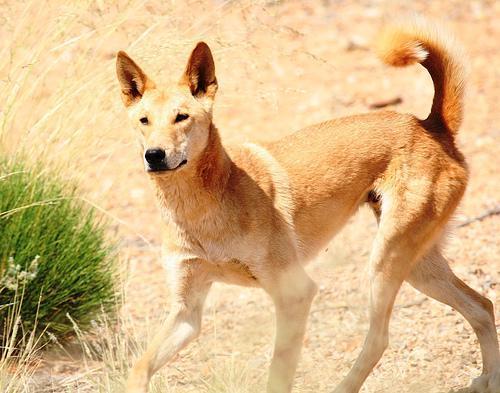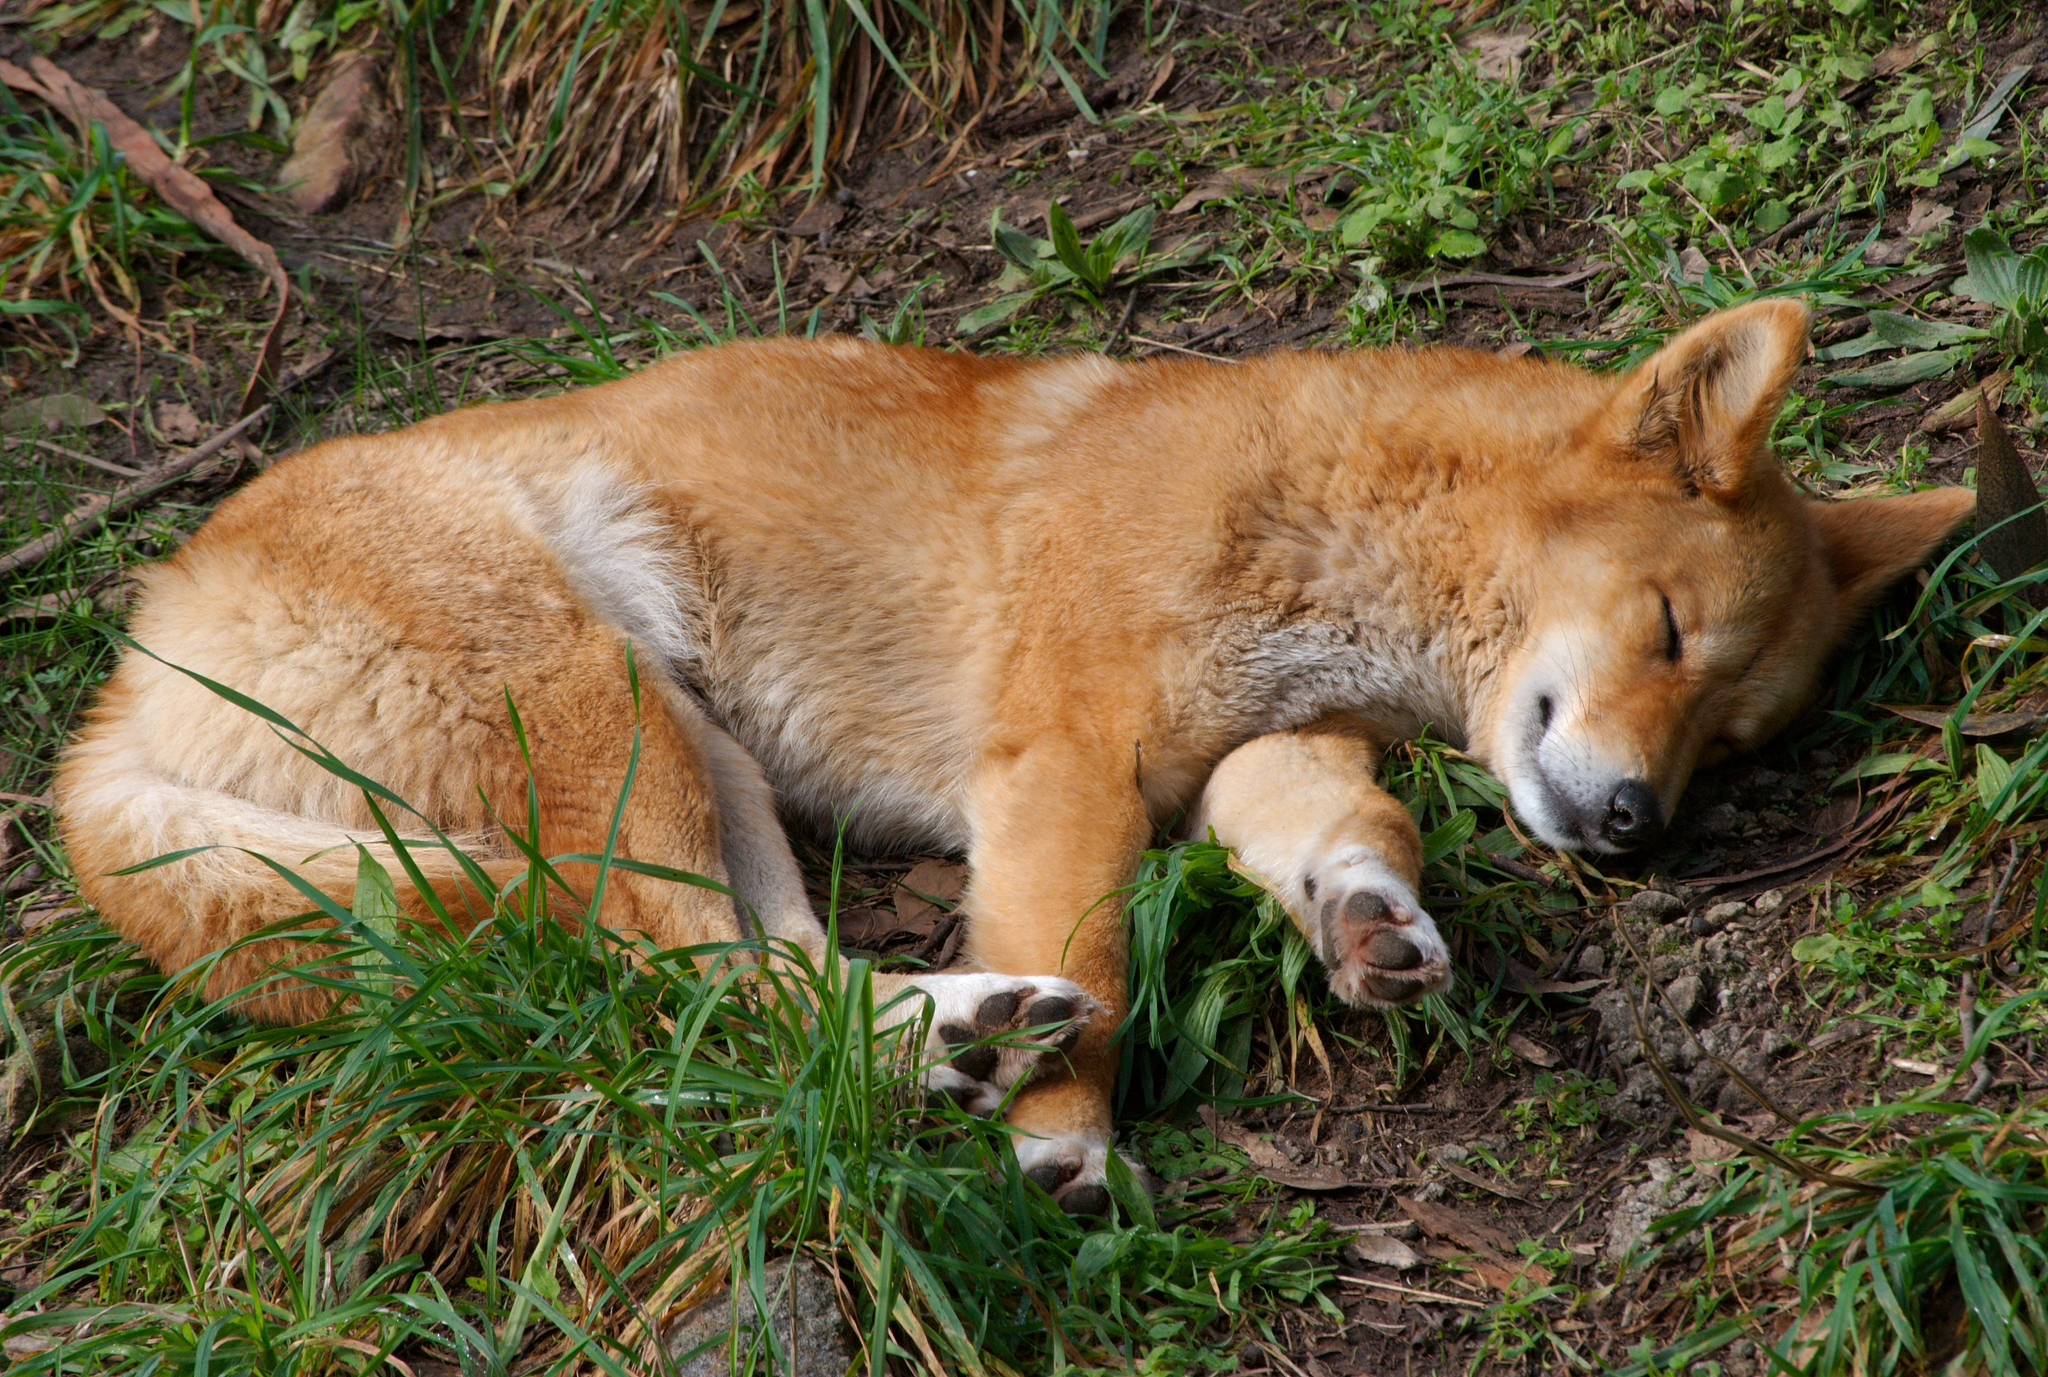The first image is the image on the left, the second image is the image on the right. Assess this claim about the two images: "the animal in the image on the left is standing on all fours.". Correct or not? Answer yes or no. Yes. The first image is the image on the left, the second image is the image on the right. For the images displayed, is the sentence "In the right image, one canine is lying on the grass." factually correct? Answer yes or no. Yes. 